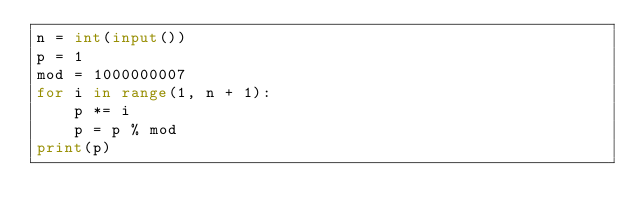Convert code to text. <code><loc_0><loc_0><loc_500><loc_500><_Python_>n = int(input())
p = 1
mod = 1000000007
for i in range(1, n + 1):
    p *= i
    p = p % mod
print(p)</code> 